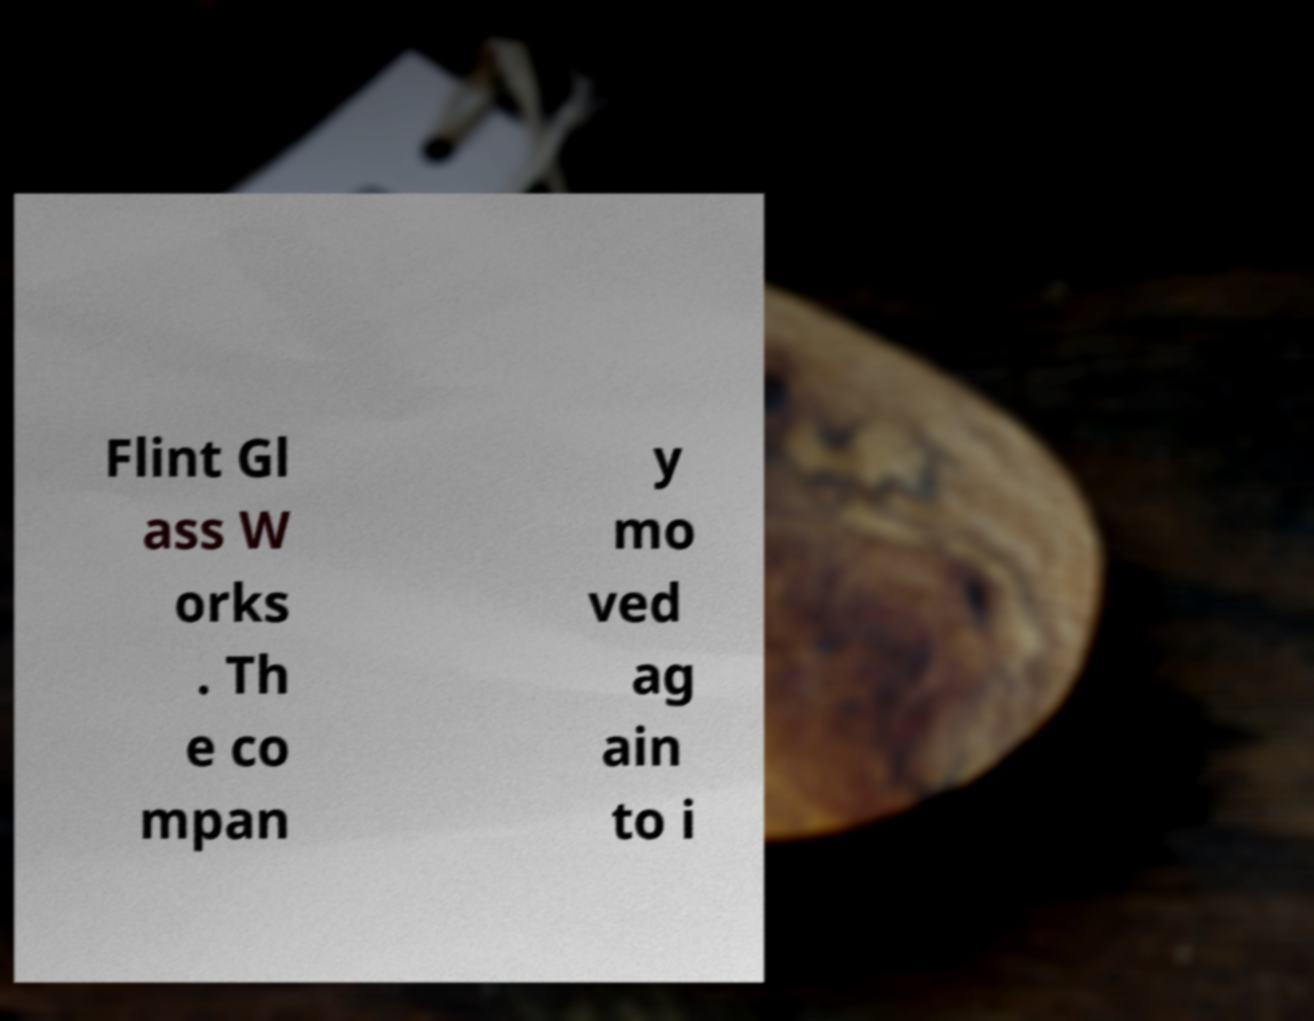I need the written content from this picture converted into text. Can you do that? Flint Gl ass W orks . Th e co mpan y mo ved ag ain to i 